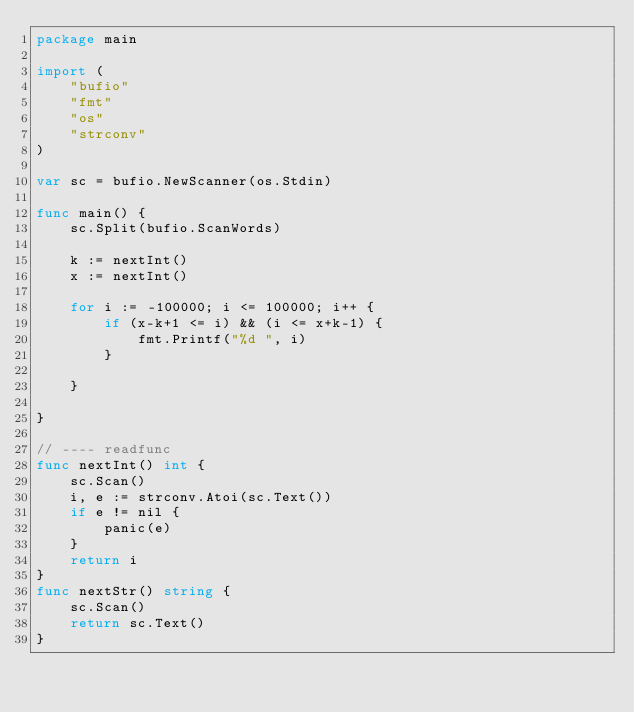Convert code to text. <code><loc_0><loc_0><loc_500><loc_500><_Go_>package main

import (
	"bufio"
	"fmt"
	"os"
	"strconv"
)

var sc = bufio.NewScanner(os.Stdin)

func main() {
	sc.Split(bufio.ScanWords)

	k := nextInt()
	x := nextInt()

	for i := -100000; i <= 100000; i++ {
		if (x-k+1 <= i) && (i <= x+k-1) {
			fmt.Printf("%d ", i)
		}

	}

}

// ---- readfunc
func nextInt() int {
	sc.Scan()
	i, e := strconv.Atoi(sc.Text())
	if e != nil {
		panic(e)
	}
	return i
}
func nextStr() string {
	sc.Scan()
	return sc.Text()
}
</code> 